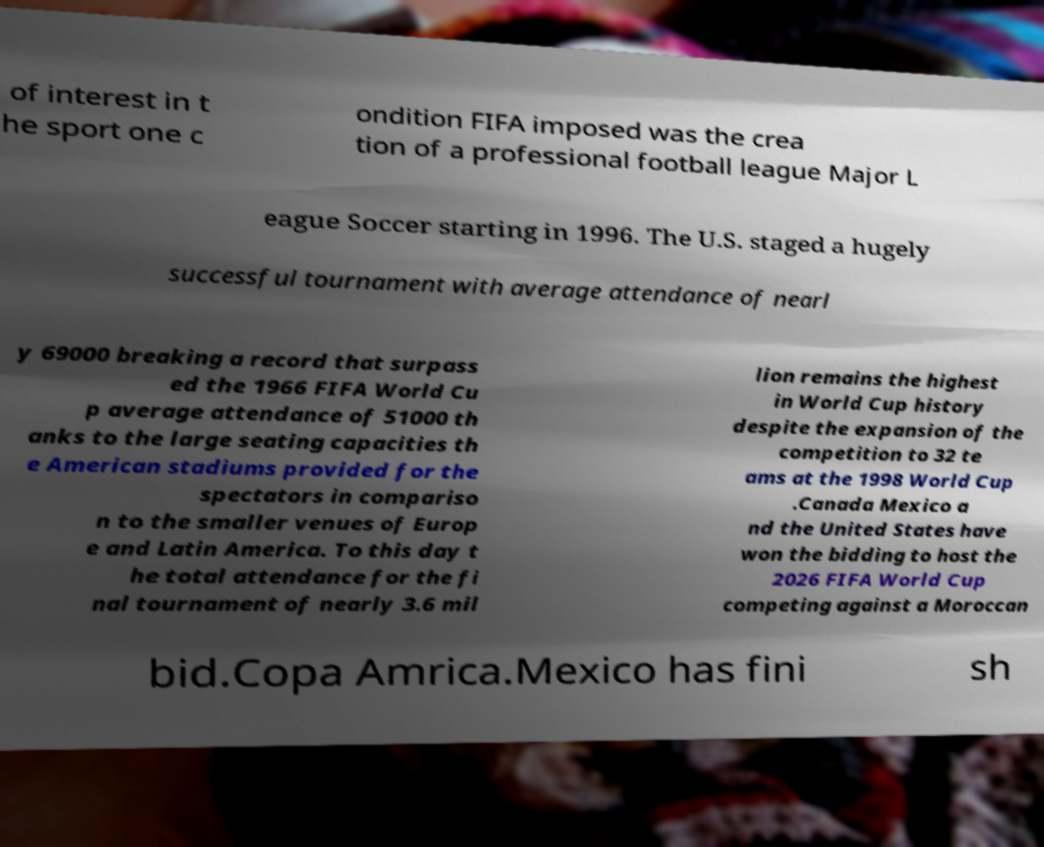There's text embedded in this image that I need extracted. Can you transcribe it verbatim? of interest in t he sport one c ondition FIFA imposed was the crea tion of a professional football league Major L eague Soccer starting in 1996. The U.S. staged a hugely successful tournament with average attendance of nearl y 69000 breaking a record that surpass ed the 1966 FIFA World Cu p average attendance of 51000 th anks to the large seating capacities th e American stadiums provided for the spectators in compariso n to the smaller venues of Europ e and Latin America. To this day t he total attendance for the fi nal tournament of nearly 3.6 mil lion remains the highest in World Cup history despite the expansion of the competition to 32 te ams at the 1998 World Cup .Canada Mexico a nd the United States have won the bidding to host the 2026 FIFA World Cup competing against a Moroccan bid.Copa Amrica.Mexico has fini sh 